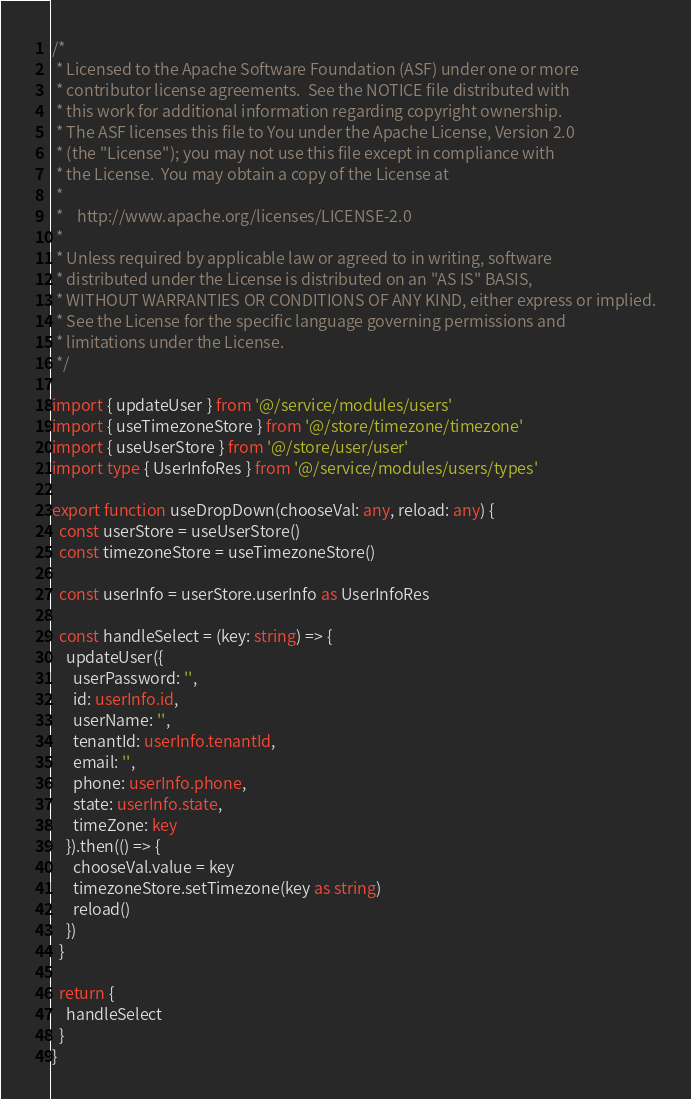Convert code to text. <code><loc_0><loc_0><loc_500><loc_500><_TypeScript_>/*
 * Licensed to the Apache Software Foundation (ASF) under one or more
 * contributor license agreements.  See the NOTICE file distributed with
 * this work for additional information regarding copyright ownership.
 * The ASF licenses this file to You under the Apache License, Version 2.0
 * (the "License"); you may not use this file except in compliance with
 * the License.  You may obtain a copy of the License at
 *
 *    http://www.apache.org/licenses/LICENSE-2.0
 *
 * Unless required by applicable law or agreed to in writing, software
 * distributed under the License is distributed on an "AS IS" BASIS,
 * WITHOUT WARRANTIES OR CONDITIONS OF ANY KIND, either express or implied.
 * See the License for the specific language governing permissions and
 * limitations under the License.
 */

import { updateUser } from '@/service/modules/users'
import { useTimezoneStore } from '@/store/timezone/timezone'
import { useUserStore } from '@/store/user/user'
import type { UserInfoRes } from '@/service/modules/users/types'

export function useDropDown(chooseVal: any, reload: any) {
  const userStore = useUserStore()
  const timezoneStore = useTimezoneStore()

  const userInfo = userStore.userInfo as UserInfoRes

  const handleSelect = (key: string) => {
    updateUser({
      userPassword: '',
      id: userInfo.id,
      userName: '',
      tenantId: userInfo.tenantId,
      email: '',
      phone: userInfo.phone,
      state: userInfo.state,
      timeZone: key
    }).then(() => {
      chooseVal.value = key
      timezoneStore.setTimezone(key as string)
      reload()
    })
  }

  return {
    handleSelect
  }
}
</code> 